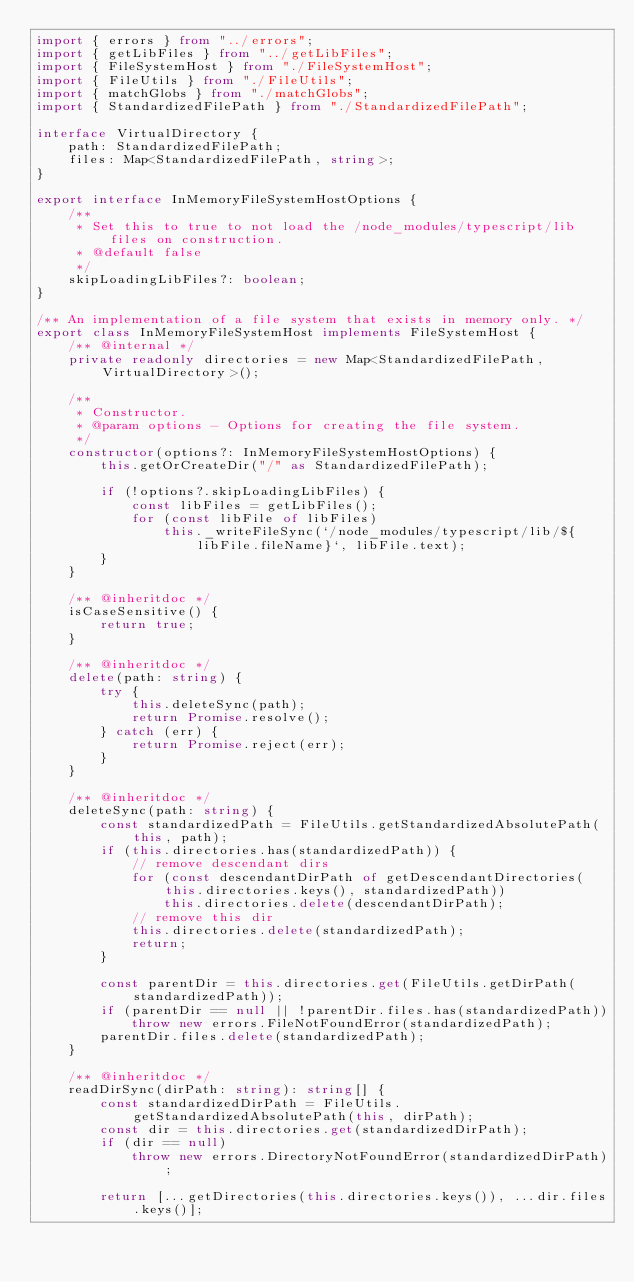Convert code to text. <code><loc_0><loc_0><loc_500><loc_500><_TypeScript_>import { errors } from "../errors";
import { getLibFiles } from "../getLibFiles";
import { FileSystemHost } from "./FileSystemHost";
import { FileUtils } from "./FileUtils";
import { matchGlobs } from "./matchGlobs";
import { StandardizedFilePath } from "./StandardizedFilePath";

interface VirtualDirectory {
    path: StandardizedFilePath;
    files: Map<StandardizedFilePath, string>;
}

export interface InMemoryFileSystemHostOptions {
    /**
     * Set this to true to not load the /node_modules/typescript/lib files on construction.
     * @default false
     */
    skipLoadingLibFiles?: boolean;
}

/** An implementation of a file system that exists in memory only. */
export class InMemoryFileSystemHost implements FileSystemHost {
    /** @internal */
    private readonly directories = new Map<StandardizedFilePath, VirtualDirectory>();

    /**
     * Constructor.
     * @param options - Options for creating the file system.
     */
    constructor(options?: InMemoryFileSystemHostOptions) {
        this.getOrCreateDir("/" as StandardizedFilePath);

        if (!options?.skipLoadingLibFiles) {
            const libFiles = getLibFiles();
            for (const libFile of libFiles)
                this._writeFileSync(`/node_modules/typescript/lib/${libFile.fileName}`, libFile.text);
        }
    }

    /** @inheritdoc */
    isCaseSensitive() {
        return true;
    }

    /** @inheritdoc */
    delete(path: string) {
        try {
            this.deleteSync(path);
            return Promise.resolve();
        } catch (err) {
            return Promise.reject(err);
        }
    }

    /** @inheritdoc */
    deleteSync(path: string) {
        const standardizedPath = FileUtils.getStandardizedAbsolutePath(this, path);
        if (this.directories.has(standardizedPath)) {
            // remove descendant dirs
            for (const descendantDirPath of getDescendantDirectories(this.directories.keys(), standardizedPath))
                this.directories.delete(descendantDirPath);
            // remove this dir
            this.directories.delete(standardizedPath);
            return;
        }

        const parentDir = this.directories.get(FileUtils.getDirPath(standardizedPath));
        if (parentDir == null || !parentDir.files.has(standardizedPath))
            throw new errors.FileNotFoundError(standardizedPath);
        parentDir.files.delete(standardizedPath);
    }

    /** @inheritdoc */
    readDirSync(dirPath: string): string[] {
        const standardizedDirPath = FileUtils.getStandardizedAbsolutePath(this, dirPath);
        const dir = this.directories.get(standardizedDirPath);
        if (dir == null)
            throw new errors.DirectoryNotFoundError(standardizedDirPath);

        return [...getDirectories(this.directories.keys()), ...dir.files.keys()];
</code> 